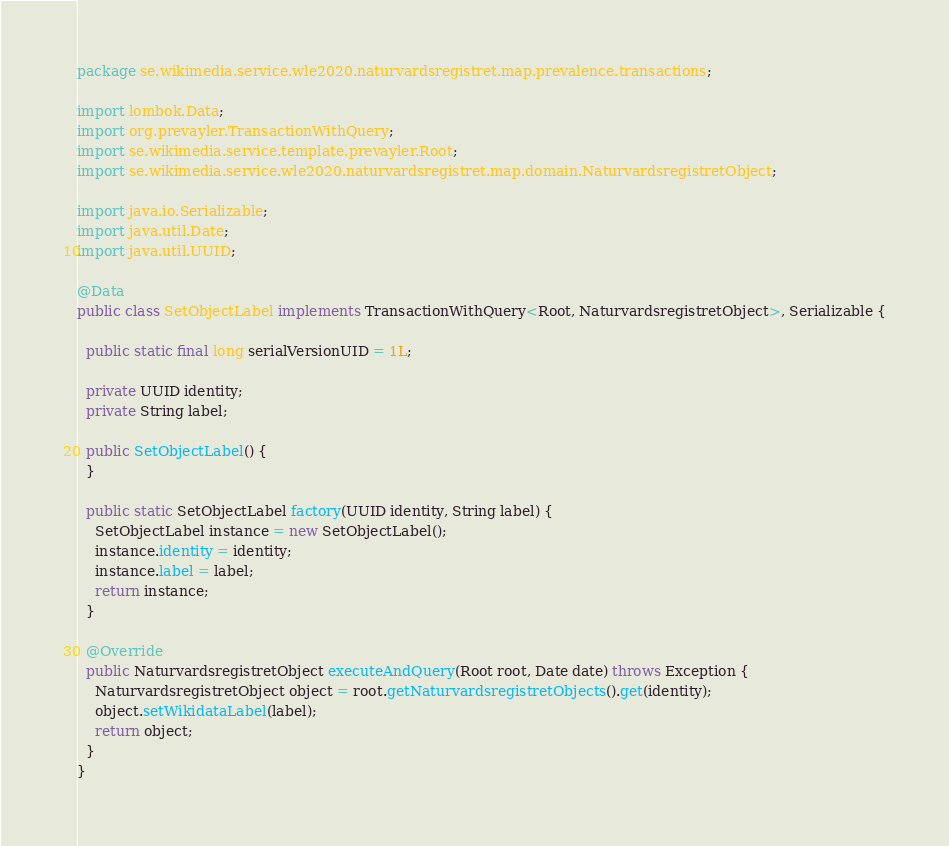Convert code to text. <code><loc_0><loc_0><loc_500><loc_500><_Java_>package se.wikimedia.service.wle2020.naturvardsregistret.map.prevalence.transactions;

import lombok.Data;
import org.prevayler.TransactionWithQuery;
import se.wikimedia.service.template.prevayler.Root;
import se.wikimedia.service.wle2020.naturvardsregistret.map.domain.NaturvardsregistretObject;

import java.io.Serializable;
import java.util.Date;
import java.util.UUID;

@Data
public class SetObjectLabel implements TransactionWithQuery<Root, NaturvardsregistretObject>, Serializable {

  public static final long serialVersionUID = 1L;

  private UUID identity;
  private String label;

  public SetObjectLabel() {
  }

  public static SetObjectLabel factory(UUID identity, String label) {
    SetObjectLabel instance = new SetObjectLabel();
    instance.identity = identity;
    instance.label = label;
    return instance;
  }

  @Override
  public NaturvardsregistretObject executeAndQuery(Root root, Date date) throws Exception {
    NaturvardsregistretObject object = root.getNaturvardsregistretObjects().get(identity);
    object.setWikidataLabel(label);
    return object;
  }
}
</code> 